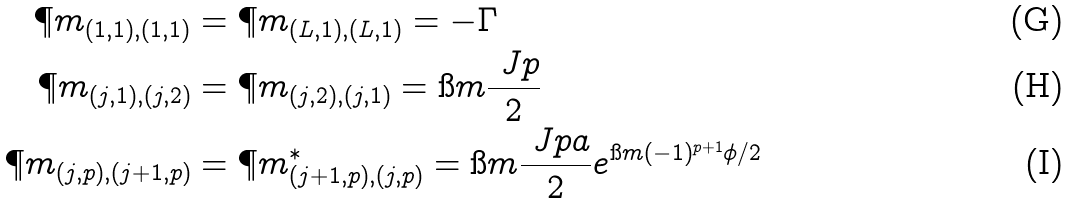Convert formula to latex. <formula><loc_0><loc_0><loc_500><loc_500>\P m _ { ( 1 , 1 ) , ( 1 , 1 ) } & = \P m _ { ( L , 1 ) , ( L , 1 ) } = - \Gamma \\ \P m _ { ( j , 1 ) , ( j , 2 ) } & = \P m _ { ( j , 2 ) , ( j , 1 ) } = \i m \frac { \ J p } { 2 } \\ \P m _ { ( j , p ) , ( j + 1 , p ) } & = \P m _ { ( j + 1 , p ) , ( j , p ) } ^ { \ast } = \i m \frac { \ J p a } { 2 } e ^ { \i m ( - 1 ) ^ { p + 1 } \phi / 2 }</formula> 